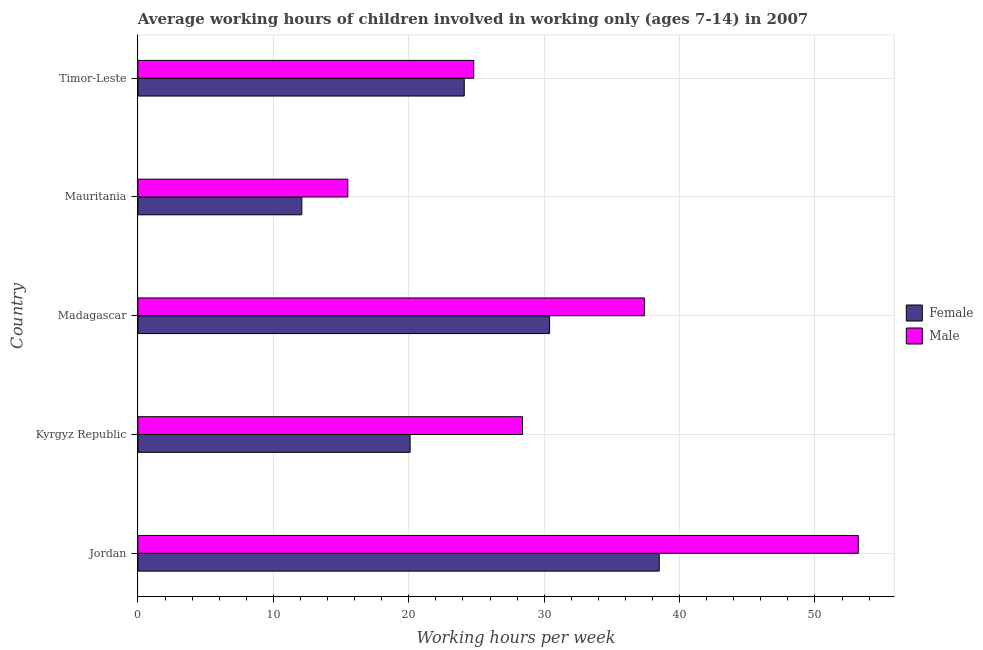How many different coloured bars are there?
Your response must be concise. 2. What is the label of the 1st group of bars from the top?
Keep it short and to the point. Timor-Leste. In how many cases, is the number of bars for a given country not equal to the number of legend labels?
Provide a succinct answer. 0. What is the average working hour of female children in Timor-Leste?
Give a very brief answer. 24.1. Across all countries, what is the maximum average working hour of female children?
Your answer should be very brief. 38.5. In which country was the average working hour of female children maximum?
Provide a succinct answer. Jordan. In which country was the average working hour of female children minimum?
Ensure brevity in your answer.  Mauritania. What is the total average working hour of female children in the graph?
Your answer should be very brief. 125.2. What is the difference between the average working hour of male children in Madagascar and the average working hour of female children in Jordan?
Keep it short and to the point. -1.1. What is the average average working hour of female children per country?
Give a very brief answer. 25.04. What is the ratio of the average working hour of female children in Jordan to that in Kyrgyz Republic?
Provide a succinct answer. 1.92. Is the average working hour of male children in Madagascar less than that in Timor-Leste?
Provide a succinct answer. No. What is the difference between the highest and the lowest average working hour of female children?
Your response must be concise. 26.4. In how many countries, is the average working hour of male children greater than the average average working hour of male children taken over all countries?
Your response must be concise. 2. What does the 2nd bar from the top in Jordan represents?
Provide a short and direct response. Female. Are all the bars in the graph horizontal?
Your response must be concise. Yes. How many countries are there in the graph?
Offer a very short reply. 5. What is the difference between two consecutive major ticks on the X-axis?
Offer a terse response. 10. Are the values on the major ticks of X-axis written in scientific E-notation?
Make the answer very short. No. How are the legend labels stacked?
Offer a very short reply. Vertical. What is the title of the graph?
Keep it short and to the point. Average working hours of children involved in working only (ages 7-14) in 2007. Does "% of gross capital formation" appear as one of the legend labels in the graph?
Your response must be concise. No. What is the label or title of the X-axis?
Offer a very short reply. Working hours per week. What is the label or title of the Y-axis?
Your response must be concise. Country. What is the Working hours per week in Female in Jordan?
Offer a very short reply. 38.5. What is the Working hours per week of Male in Jordan?
Provide a succinct answer. 53.2. What is the Working hours per week of Female in Kyrgyz Republic?
Provide a succinct answer. 20.1. What is the Working hours per week of Male in Kyrgyz Republic?
Provide a short and direct response. 28.4. What is the Working hours per week of Female in Madagascar?
Your response must be concise. 30.4. What is the Working hours per week of Male in Madagascar?
Give a very brief answer. 37.4. What is the Working hours per week in Female in Mauritania?
Keep it short and to the point. 12.1. What is the Working hours per week in Male in Mauritania?
Offer a very short reply. 15.5. What is the Working hours per week in Female in Timor-Leste?
Your answer should be compact. 24.1. What is the Working hours per week in Male in Timor-Leste?
Your response must be concise. 24.8. Across all countries, what is the maximum Working hours per week of Female?
Give a very brief answer. 38.5. Across all countries, what is the maximum Working hours per week in Male?
Give a very brief answer. 53.2. Across all countries, what is the minimum Working hours per week in Female?
Keep it short and to the point. 12.1. What is the total Working hours per week in Female in the graph?
Make the answer very short. 125.2. What is the total Working hours per week in Male in the graph?
Provide a short and direct response. 159.3. What is the difference between the Working hours per week in Female in Jordan and that in Kyrgyz Republic?
Your answer should be compact. 18.4. What is the difference between the Working hours per week of Male in Jordan and that in Kyrgyz Republic?
Your response must be concise. 24.8. What is the difference between the Working hours per week in Female in Jordan and that in Mauritania?
Provide a short and direct response. 26.4. What is the difference between the Working hours per week of Male in Jordan and that in Mauritania?
Ensure brevity in your answer.  37.7. What is the difference between the Working hours per week in Female in Jordan and that in Timor-Leste?
Keep it short and to the point. 14.4. What is the difference between the Working hours per week in Male in Jordan and that in Timor-Leste?
Provide a succinct answer. 28.4. What is the difference between the Working hours per week in Female in Kyrgyz Republic and that in Mauritania?
Give a very brief answer. 8. What is the difference between the Working hours per week of Male in Kyrgyz Republic and that in Mauritania?
Your answer should be very brief. 12.9. What is the difference between the Working hours per week of Female in Kyrgyz Republic and that in Timor-Leste?
Offer a very short reply. -4. What is the difference between the Working hours per week of Female in Madagascar and that in Mauritania?
Your answer should be very brief. 18.3. What is the difference between the Working hours per week of Male in Madagascar and that in Mauritania?
Ensure brevity in your answer.  21.9. What is the difference between the Working hours per week of Female in Madagascar and that in Timor-Leste?
Give a very brief answer. 6.3. What is the difference between the Working hours per week in Female in Mauritania and that in Timor-Leste?
Your answer should be compact. -12. What is the difference between the Working hours per week in Female in Kyrgyz Republic and the Working hours per week in Male in Madagascar?
Keep it short and to the point. -17.3. What is the difference between the Working hours per week in Female in Kyrgyz Republic and the Working hours per week in Male in Timor-Leste?
Your response must be concise. -4.7. What is the difference between the Working hours per week of Female in Mauritania and the Working hours per week of Male in Timor-Leste?
Keep it short and to the point. -12.7. What is the average Working hours per week in Female per country?
Ensure brevity in your answer.  25.04. What is the average Working hours per week in Male per country?
Keep it short and to the point. 31.86. What is the difference between the Working hours per week in Female and Working hours per week in Male in Jordan?
Your response must be concise. -14.7. What is the difference between the Working hours per week in Female and Working hours per week in Male in Mauritania?
Offer a terse response. -3.4. What is the difference between the Working hours per week of Female and Working hours per week of Male in Timor-Leste?
Offer a very short reply. -0.7. What is the ratio of the Working hours per week of Female in Jordan to that in Kyrgyz Republic?
Keep it short and to the point. 1.92. What is the ratio of the Working hours per week in Male in Jordan to that in Kyrgyz Republic?
Make the answer very short. 1.87. What is the ratio of the Working hours per week of Female in Jordan to that in Madagascar?
Provide a succinct answer. 1.27. What is the ratio of the Working hours per week of Male in Jordan to that in Madagascar?
Offer a terse response. 1.42. What is the ratio of the Working hours per week of Female in Jordan to that in Mauritania?
Your answer should be compact. 3.18. What is the ratio of the Working hours per week in Male in Jordan to that in Mauritania?
Offer a very short reply. 3.43. What is the ratio of the Working hours per week in Female in Jordan to that in Timor-Leste?
Make the answer very short. 1.6. What is the ratio of the Working hours per week of Male in Jordan to that in Timor-Leste?
Keep it short and to the point. 2.15. What is the ratio of the Working hours per week in Female in Kyrgyz Republic to that in Madagascar?
Provide a short and direct response. 0.66. What is the ratio of the Working hours per week in Male in Kyrgyz Republic to that in Madagascar?
Provide a succinct answer. 0.76. What is the ratio of the Working hours per week of Female in Kyrgyz Republic to that in Mauritania?
Give a very brief answer. 1.66. What is the ratio of the Working hours per week of Male in Kyrgyz Republic to that in Mauritania?
Provide a short and direct response. 1.83. What is the ratio of the Working hours per week of Female in Kyrgyz Republic to that in Timor-Leste?
Provide a short and direct response. 0.83. What is the ratio of the Working hours per week in Male in Kyrgyz Republic to that in Timor-Leste?
Offer a very short reply. 1.15. What is the ratio of the Working hours per week of Female in Madagascar to that in Mauritania?
Provide a short and direct response. 2.51. What is the ratio of the Working hours per week in Male in Madagascar to that in Mauritania?
Provide a short and direct response. 2.41. What is the ratio of the Working hours per week in Female in Madagascar to that in Timor-Leste?
Your answer should be very brief. 1.26. What is the ratio of the Working hours per week of Male in Madagascar to that in Timor-Leste?
Provide a succinct answer. 1.51. What is the ratio of the Working hours per week in Female in Mauritania to that in Timor-Leste?
Your response must be concise. 0.5. What is the difference between the highest and the second highest Working hours per week in Female?
Provide a succinct answer. 8.1. What is the difference between the highest and the lowest Working hours per week in Female?
Provide a succinct answer. 26.4. What is the difference between the highest and the lowest Working hours per week in Male?
Offer a terse response. 37.7. 